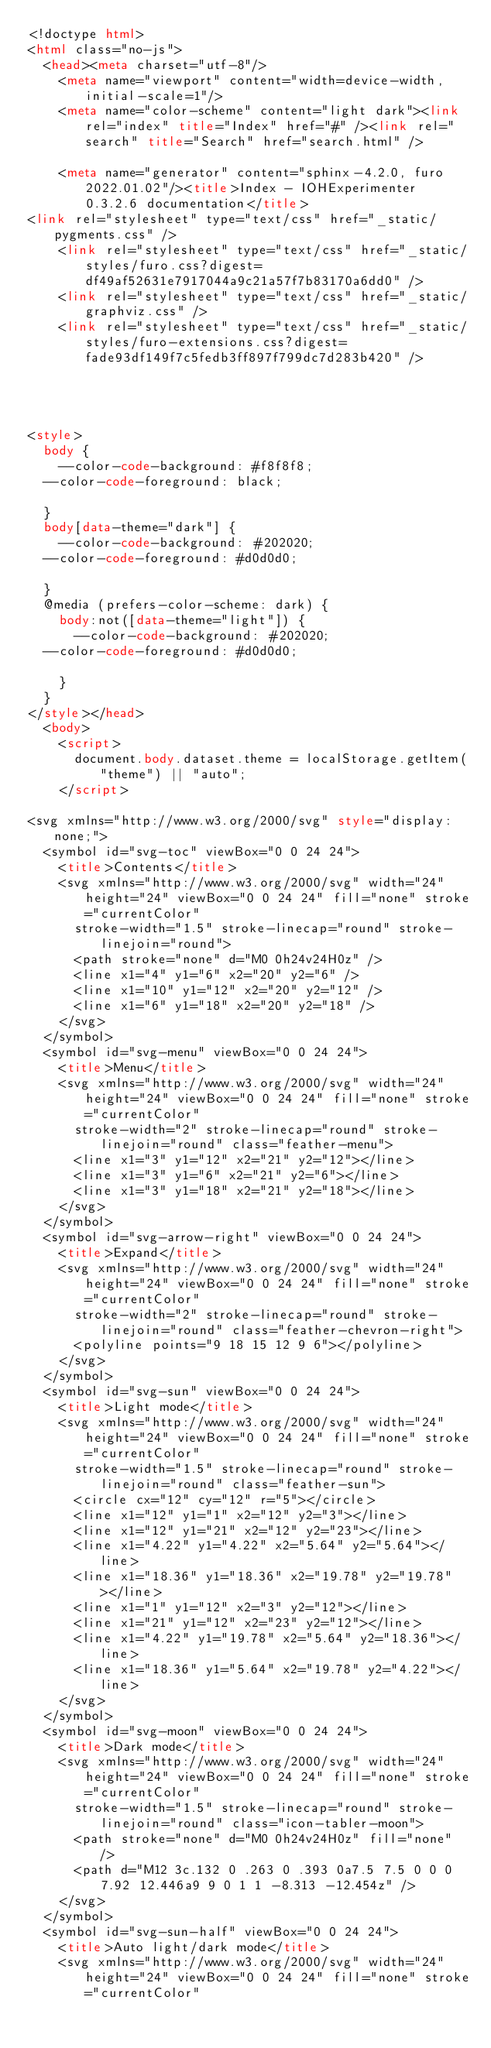Convert code to text. <code><loc_0><loc_0><loc_500><loc_500><_HTML_><!doctype html>
<html class="no-js">
  <head><meta charset="utf-8"/>
    <meta name="viewport" content="width=device-width,initial-scale=1"/>
    <meta name="color-scheme" content="light dark"><link rel="index" title="Index" href="#" /><link rel="search" title="Search" href="search.html" />

    <meta name="generator" content="sphinx-4.2.0, furo 2022.01.02"/><title>Index - IOHExperimenter 0.3.2.6 documentation</title>
<link rel="stylesheet" type="text/css" href="_static/pygments.css" />
    <link rel="stylesheet" type="text/css" href="_static/styles/furo.css?digest=df49af52631e7917044a9c21a57f7b83170a6dd0" />
    <link rel="stylesheet" type="text/css" href="_static/graphviz.css" />
    <link rel="stylesheet" type="text/css" href="_static/styles/furo-extensions.css?digest=fade93df149f7c5fedb3ff897f799dc7d283b420" />
    
    


<style>
  body {
    --color-code-background: #f8f8f8;
  --color-code-foreground: black;
  
  }
  body[data-theme="dark"] {
    --color-code-background: #202020;
  --color-code-foreground: #d0d0d0;
  
  }
  @media (prefers-color-scheme: dark) {
    body:not([data-theme="light"]) {
      --color-code-background: #202020;
  --color-code-foreground: #d0d0d0;
  
    }
  }
</style></head>
  <body>
    <script>
      document.body.dataset.theme = localStorage.getItem("theme") || "auto";
    </script>
    
<svg xmlns="http://www.w3.org/2000/svg" style="display: none;">
  <symbol id="svg-toc" viewBox="0 0 24 24">
    <title>Contents</title>
    <svg xmlns="http://www.w3.org/2000/svg" width="24" height="24" viewBox="0 0 24 24" fill="none" stroke="currentColor"
      stroke-width="1.5" stroke-linecap="round" stroke-linejoin="round">
      <path stroke="none" d="M0 0h24v24H0z" />
      <line x1="4" y1="6" x2="20" y2="6" />
      <line x1="10" y1="12" x2="20" y2="12" />
      <line x1="6" y1="18" x2="20" y2="18" />
    </svg>
  </symbol>
  <symbol id="svg-menu" viewBox="0 0 24 24">
    <title>Menu</title>
    <svg xmlns="http://www.w3.org/2000/svg" width="24" height="24" viewBox="0 0 24 24" fill="none" stroke="currentColor"
      stroke-width="2" stroke-linecap="round" stroke-linejoin="round" class="feather-menu">
      <line x1="3" y1="12" x2="21" y2="12"></line>
      <line x1="3" y1="6" x2="21" y2="6"></line>
      <line x1="3" y1="18" x2="21" y2="18"></line>
    </svg>
  </symbol>
  <symbol id="svg-arrow-right" viewBox="0 0 24 24">
    <title>Expand</title>
    <svg xmlns="http://www.w3.org/2000/svg" width="24" height="24" viewBox="0 0 24 24" fill="none" stroke="currentColor"
      stroke-width="2" stroke-linecap="round" stroke-linejoin="round" class="feather-chevron-right">
      <polyline points="9 18 15 12 9 6"></polyline>
    </svg>
  </symbol>
  <symbol id="svg-sun" viewBox="0 0 24 24">
    <title>Light mode</title>
    <svg xmlns="http://www.w3.org/2000/svg" width="24" height="24" viewBox="0 0 24 24" fill="none" stroke="currentColor"
      stroke-width="1.5" stroke-linecap="round" stroke-linejoin="round" class="feather-sun">
      <circle cx="12" cy="12" r="5"></circle>
      <line x1="12" y1="1" x2="12" y2="3"></line>
      <line x1="12" y1="21" x2="12" y2="23"></line>
      <line x1="4.22" y1="4.22" x2="5.64" y2="5.64"></line>
      <line x1="18.36" y1="18.36" x2="19.78" y2="19.78"></line>
      <line x1="1" y1="12" x2="3" y2="12"></line>
      <line x1="21" y1="12" x2="23" y2="12"></line>
      <line x1="4.22" y1="19.78" x2="5.64" y2="18.36"></line>
      <line x1="18.36" y1="5.64" x2="19.78" y2="4.22"></line>
    </svg>
  </symbol>
  <symbol id="svg-moon" viewBox="0 0 24 24">
    <title>Dark mode</title>
    <svg xmlns="http://www.w3.org/2000/svg" width="24" height="24" viewBox="0 0 24 24" fill="none" stroke="currentColor"
      stroke-width="1.5" stroke-linecap="round" stroke-linejoin="round" class="icon-tabler-moon">
      <path stroke="none" d="M0 0h24v24H0z" fill="none" />
      <path d="M12 3c.132 0 .263 0 .393 0a7.5 7.5 0 0 0 7.92 12.446a9 9 0 1 1 -8.313 -12.454z" />
    </svg>
  </symbol>
  <symbol id="svg-sun-half" viewBox="0 0 24 24">
    <title>Auto light/dark mode</title>
    <svg xmlns="http://www.w3.org/2000/svg" width="24" height="24" viewBox="0 0 24 24" fill="none" stroke="currentColor"</code> 